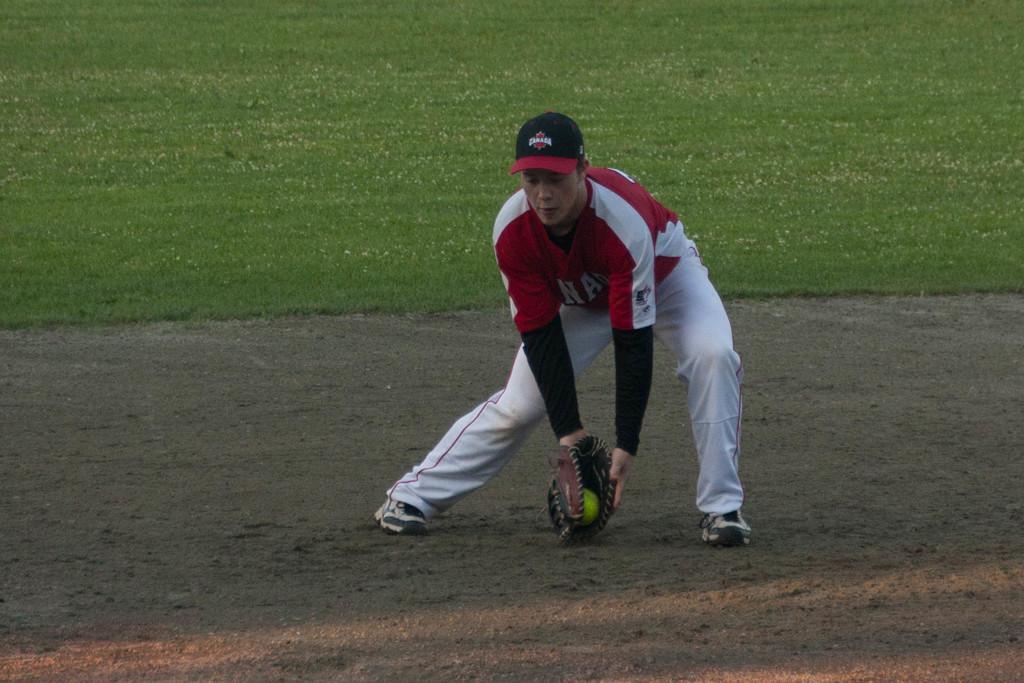In one or two sentences, can you explain what this image depicts? In this picture I can observe a baseball player in the middle of the picture. He is wearing red and white color jersey and a cap on his head. I can observe a glove to his hand. In the background I can observe some grass on the ground. 